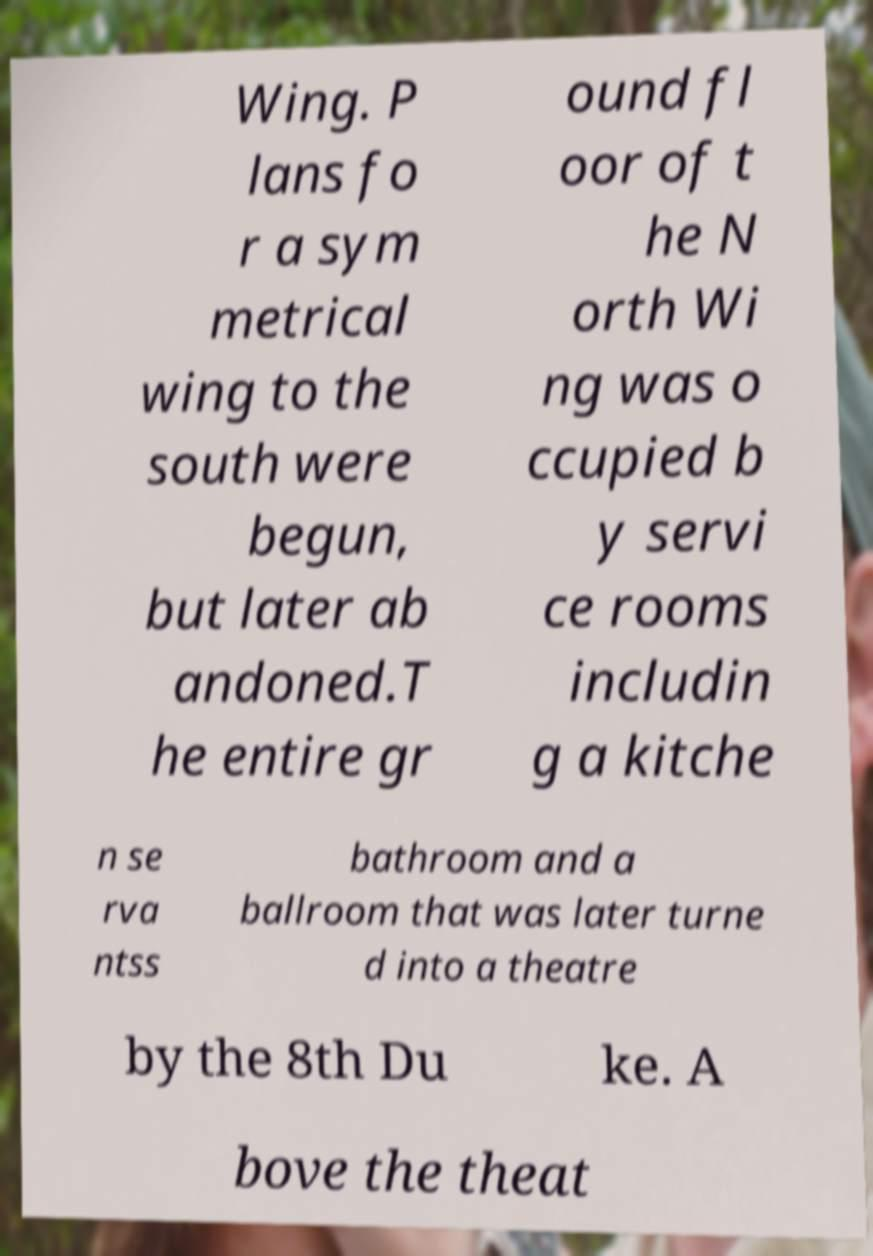There's text embedded in this image that I need extracted. Can you transcribe it verbatim? Wing. P lans fo r a sym metrical wing to the south were begun, but later ab andoned.T he entire gr ound fl oor of t he N orth Wi ng was o ccupied b y servi ce rooms includin g a kitche n se rva ntss bathroom and a ballroom that was later turne d into a theatre by the 8th Du ke. A bove the theat 